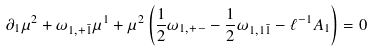Convert formula to latex. <formula><loc_0><loc_0><loc_500><loc_500>\partial _ { 1 } \mu ^ { 2 } + \omega _ { 1 , + { \bar { 1 } } } \mu ^ { 1 } + \mu ^ { 2 } \left ( { \frac { 1 } { 2 } } \omega _ { 1 , + - } - { \frac { 1 } { 2 } } \omega _ { 1 , 1 { \bar { 1 } } } - \ell ^ { - 1 } A _ { 1 } \right ) = 0</formula> 